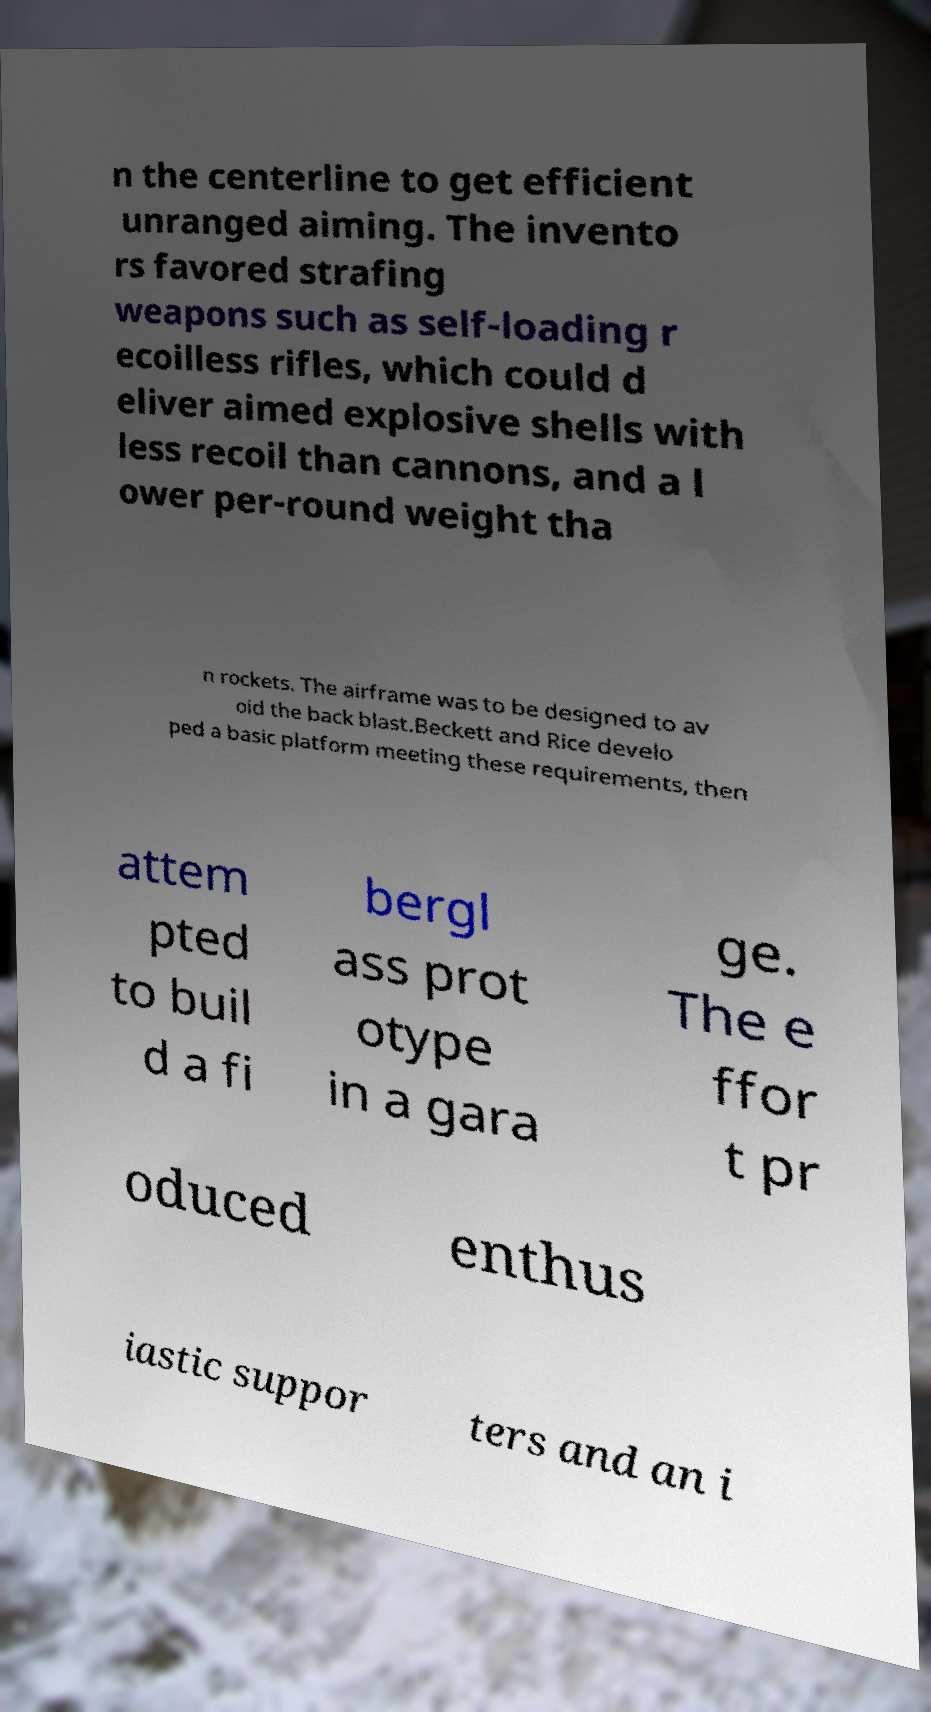Please identify and transcribe the text found in this image. n the centerline to get efficient unranged aiming. The invento rs favored strafing weapons such as self-loading r ecoilless rifles, which could d eliver aimed explosive shells with less recoil than cannons, and a l ower per-round weight tha n rockets. The airframe was to be designed to av oid the back blast.Beckett and Rice develo ped a basic platform meeting these requirements, then attem pted to buil d a fi bergl ass prot otype in a gara ge. The e ffor t pr oduced enthus iastic suppor ters and an i 